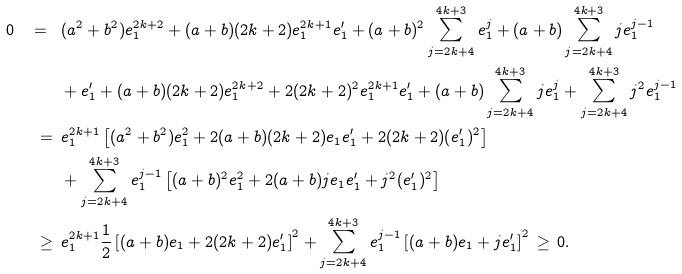<formula> <loc_0><loc_0><loc_500><loc_500>\, 0 \, \ = \ & \, ( a ^ { 2 } + b ^ { 2 } ) e _ { 1 } ^ { 2 k + 2 } + ( a + b ) ( 2 k + 2 ) e _ { 1 } ^ { 2 k + 1 } e _ { 1 } ^ { \prime } + ( a + b ) ^ { 2 } \sum _ { j = 2 k + 4 } ^ { 4 k + 3 } e _ { 1 } ^ { j } + ( a + b ) \sum _ { j = 2 k + 4 } ^ { 4 k + 3 } j e _ { 1 } ^ { j - 1 } \\ & \, + e _ { 1 } ^ { \prime } + ( a + b ) ( 2 k + 2 ) e _ { 1 } ^ { 2 k + 2 } + 2 ( 2 k + 2 ) ^ { 2 } e _ { 1 } ^ { 2 k + 1 } e _ { 1 } ^ { \prime } + ( a + b ) \sum _ { j = 2 k + 4 } ^ { 4 k + 3 } j e _ { 1 } ^ { j } + \sum _ { j = 2 k + 4 } ^ { 4 k + 3 } j ^ { 2 } e _ { 1 } ^ { j - 1 } \\ \ = \ & \, e _ { 1 } ^ { 2 k + 1 } \left [ ( a ^ { 2 } + b ^ { 2 } ) e _ { 1 } ^ { 2 } + 2 ( a + b ) ( 2 k + 2 ) e _ { 1 } e _ { 1 } ^ { \prime } + 2 ( 2 k + 2 ) ( e _ { 1 } ^ { \prime } ) ^ { 2 } \right ] \\ & \, + \sum _ { j = 2 k + 4 } ^ { 4 k + 3 } e _ { 1 } ^ { j - 1 } \left [ ( a + b ) ^ { 2 } e _ { 1 } ^ { 2 } + 2 ( a + b ) j e _ { 1 } e _ { 1 } ^ { \prime } + j ^ { 2 } ( e _ { 1 } ^ { \prime } ) ^ { 2 } \right ] \\ \ \geq \ & \, e _ { 1 } ^ { 2 k + 1 } \frac { 1 } { 2 } \left [ ( a + b ) e _ { 1 } + 2 ( 2 k + 2 ) e _ { 1 } ^ { \prime } \right ] ^ { 2 } + \sum _ { j = 2 k + 4 } ^ { 4 k + 3 } e _ { 1 } ^ { j - 1 } \left [ ( a + b ) e _ { 1 } + j e _ { 1 } ^ { \prime } \right ] ^ { 2 } \, \geq \, 0 .</formula> 